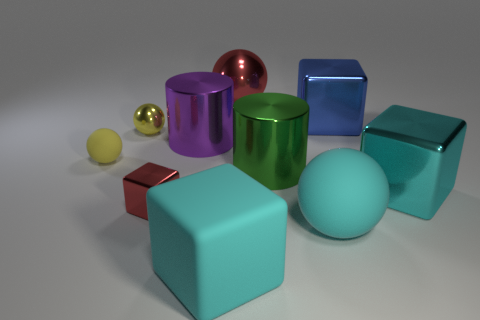Are there an equal number of green cylinders that are on the left side of the yellow metal ball and tiny red objects that are behind the large cyan shiny thing?
Provide a short and direct response. Yes. What color is the other object that is the same shape as the green metal object?
Your answer should be compact. Purple. How many shiny things have the same color as the large matte sphere?
Give a very brief answer. 1. Is the shape of the red metal object that is behind the green metal thing the same as  the yellow matte object?
Make the answer very short. Yes. There is a tiny metallic object that is in front of the large cylinder that is on the left side of the large red sphere on the right side of the large purple metallic cylinder; what is its shape?
Keep it short and to the point. Cube. The purple cylinder has what size?
Your answer should be very brief. Large. What color is the tiny ball that is made of the same material as the green cylinder?
Provide a short and direct response. Yellow. How many large objects are made of the same material as the small block?
Your answer should be compact. 5. Is the color of the large shiny ball the same as the tiny object in front of the large green metal object?
Give a very brief answer. Yes. The big ball that is behind the cyan matte object to the right of the big red sphere is what color?
Your answer should be very brief. Red. 